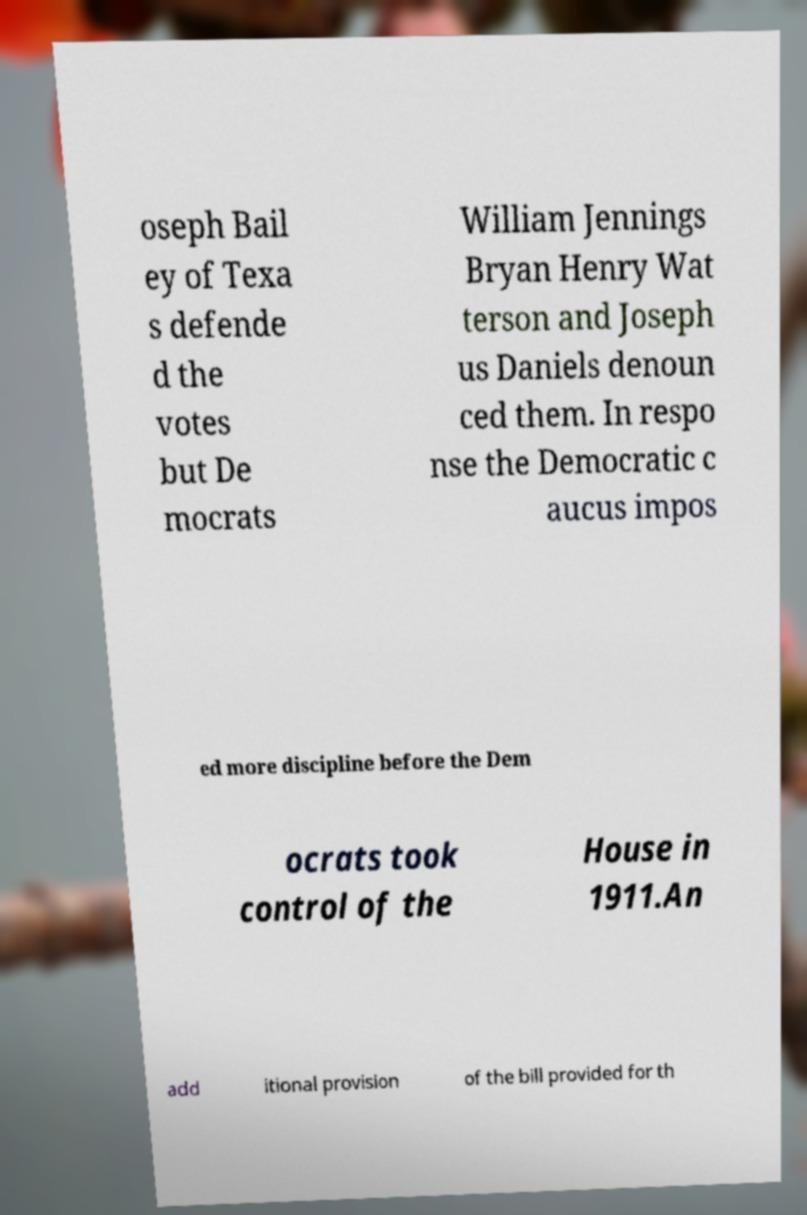For documentation purposes, I need the text within this image transcribed. Could you provide that? oseph Bail ey of Texa s defende d the votes but De mocrats William Jennings Bryan Henry Wat terson and Joseph us Daniels denoun ced them. In respo nse the Democratic c aucus impos ed more discipline before the Dem ocrats took control of the House in 1911.An add itional provision of the bill provided for th 